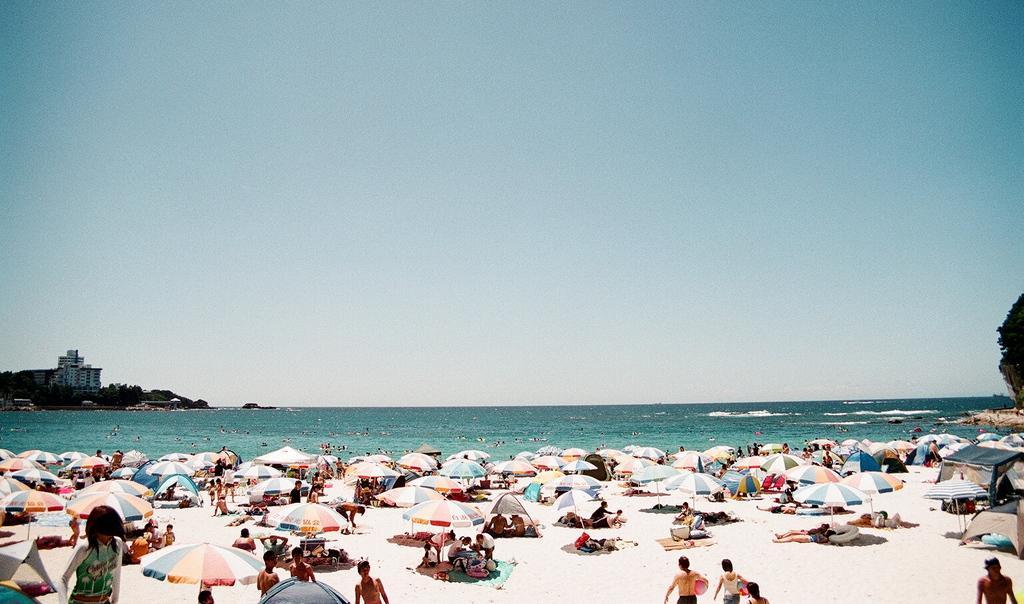Could you give a brief overview of what you see in this image? In this image there are parasols and we can see people. In the background there is water and we can see trees, buildings and sky. 